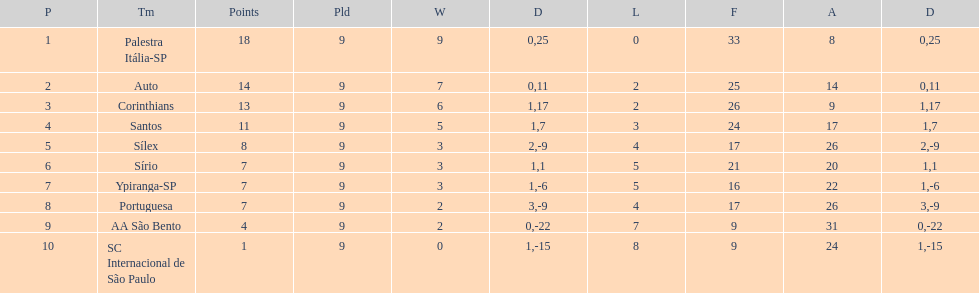Which team was the top scoring team? Palestra Itália-SP. 